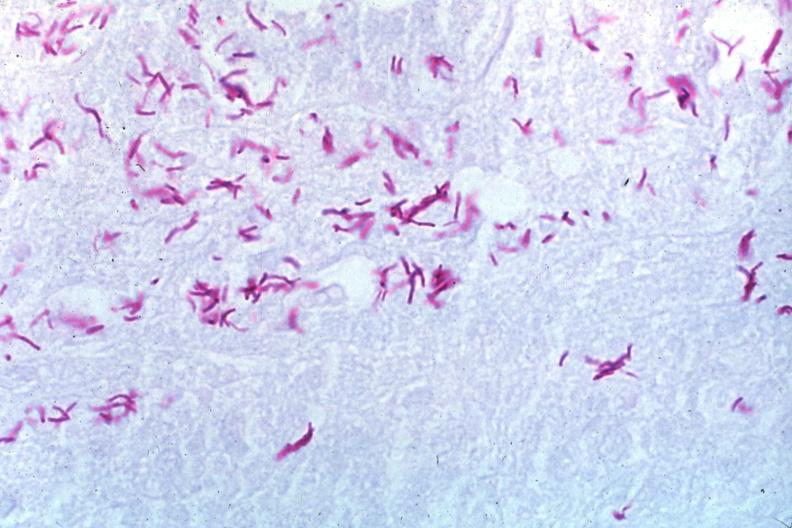s tuberculosis present?
Answer the question using a single word or phrase. Yes 